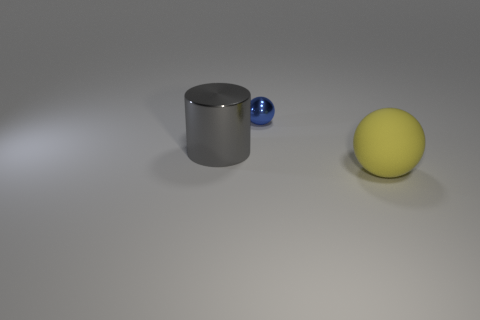Subtract 1 spheres. How many spheres are left? 1 Add 1 big yellow shiny spheres. How many objects exist? 4 Subtract all yellow spheres. How many spheres are left? 1 Subtract all cylinders. How many objects are left? 2 Subtract all red spheres. Subtract all green blocks. How many spheres are left? 2 Subtract all yellow cylinders. Subtract all big gray objects. How many objects are left? 2 Add 3 large matte things. How many large matte things are left? 4 Add 1 big brown cubes. How many big brown cubes exist? 1 Subtract 0 green spheres. How many objects are left? 3 Subtract all cyan cubes. How many brown spheres are left? 0 